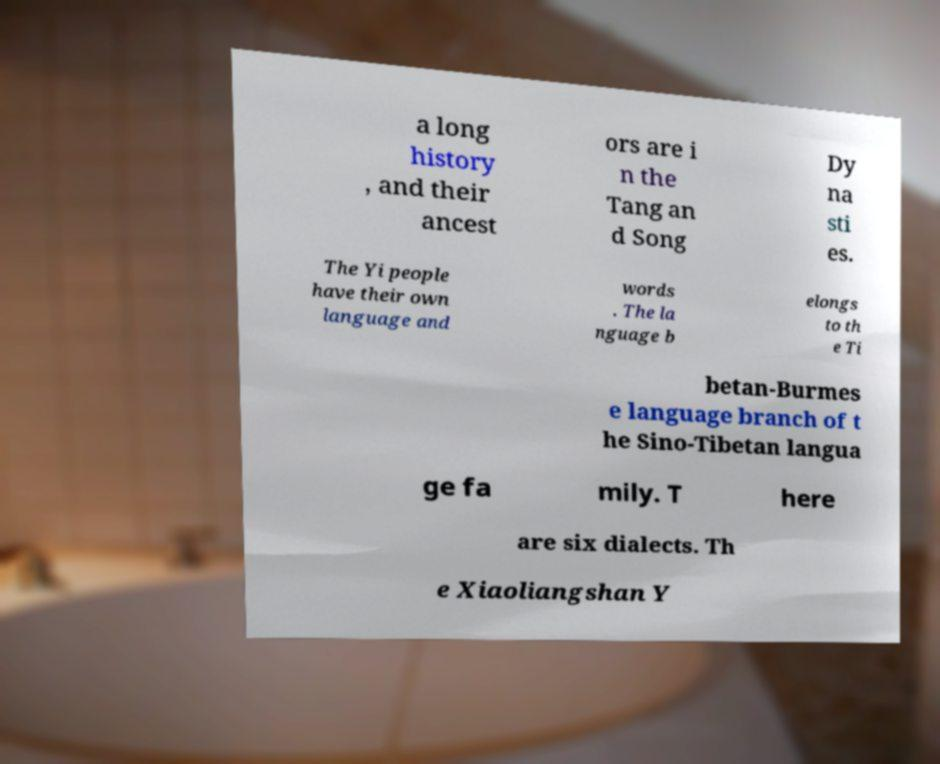Can you read and provide the text displayed in the image?This photo seems to have some interesting text. Can you extract and type it out for me? a long history , and their ancest ors are i n the Tang an d Song Dy na sti es. The Yi people have their own language and words . The la nguage b elongs to th e Ti betan-Burmes e language branch of t he Sino-Tibetan langua ge fa mily. T here are six dialects. Th e Xiaoliangshan Y 